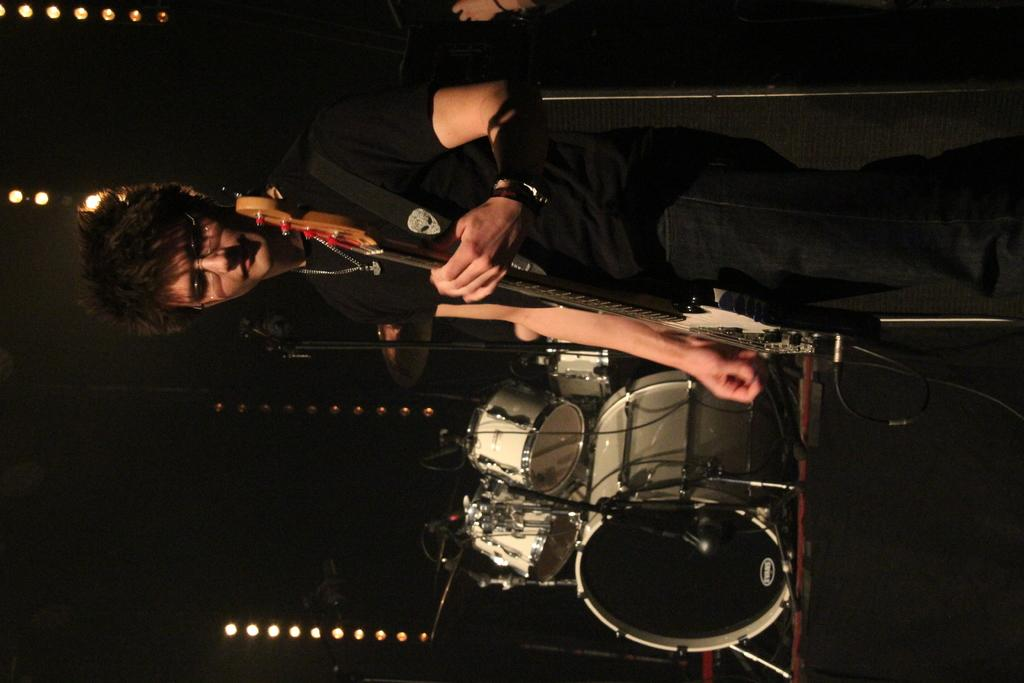Who is the main subject in the image? There is a man in the image. What is the man holding in the image? The man is holding a guitar. What is the man wearing in the image? The man is wearing a black t-shirt. What can be seen in the background of the image? There are music instruments in the background of the image. What color are the music instruments in the image? The music instruments are white in color. What type of operation is the man performing on the pot in the image? There is no pot present in the image, and the man is not performing any operation. How many feet can be seen in the image? There is no reference to feet in the image, so it is not possible to determine how many can be seen. 